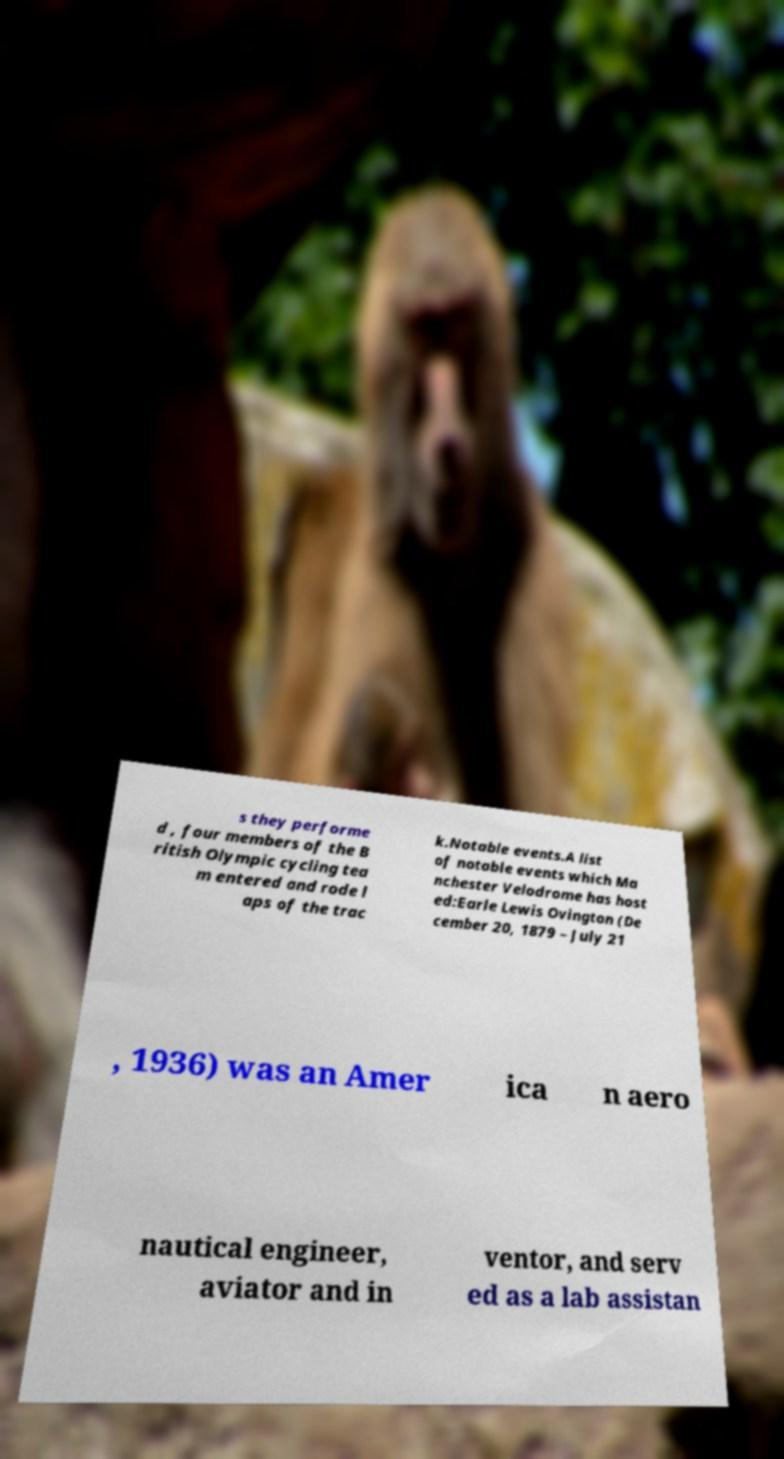There's text embedded in this image that I need extracted. Can you transcribe it verbatim? s they performe d , four members of the B ritish Olympic cycling tea m entered and rode l aps of the trac k.Notable events.A list of notable events which Ma nchester Velodrome has host ed:Earle Lewis Ovington (De cember 20, 1879 – July 21 , 1936) was an Amer ica n aero nautical engineer, aviator and in ventor, and serv ed as a lab assistan 